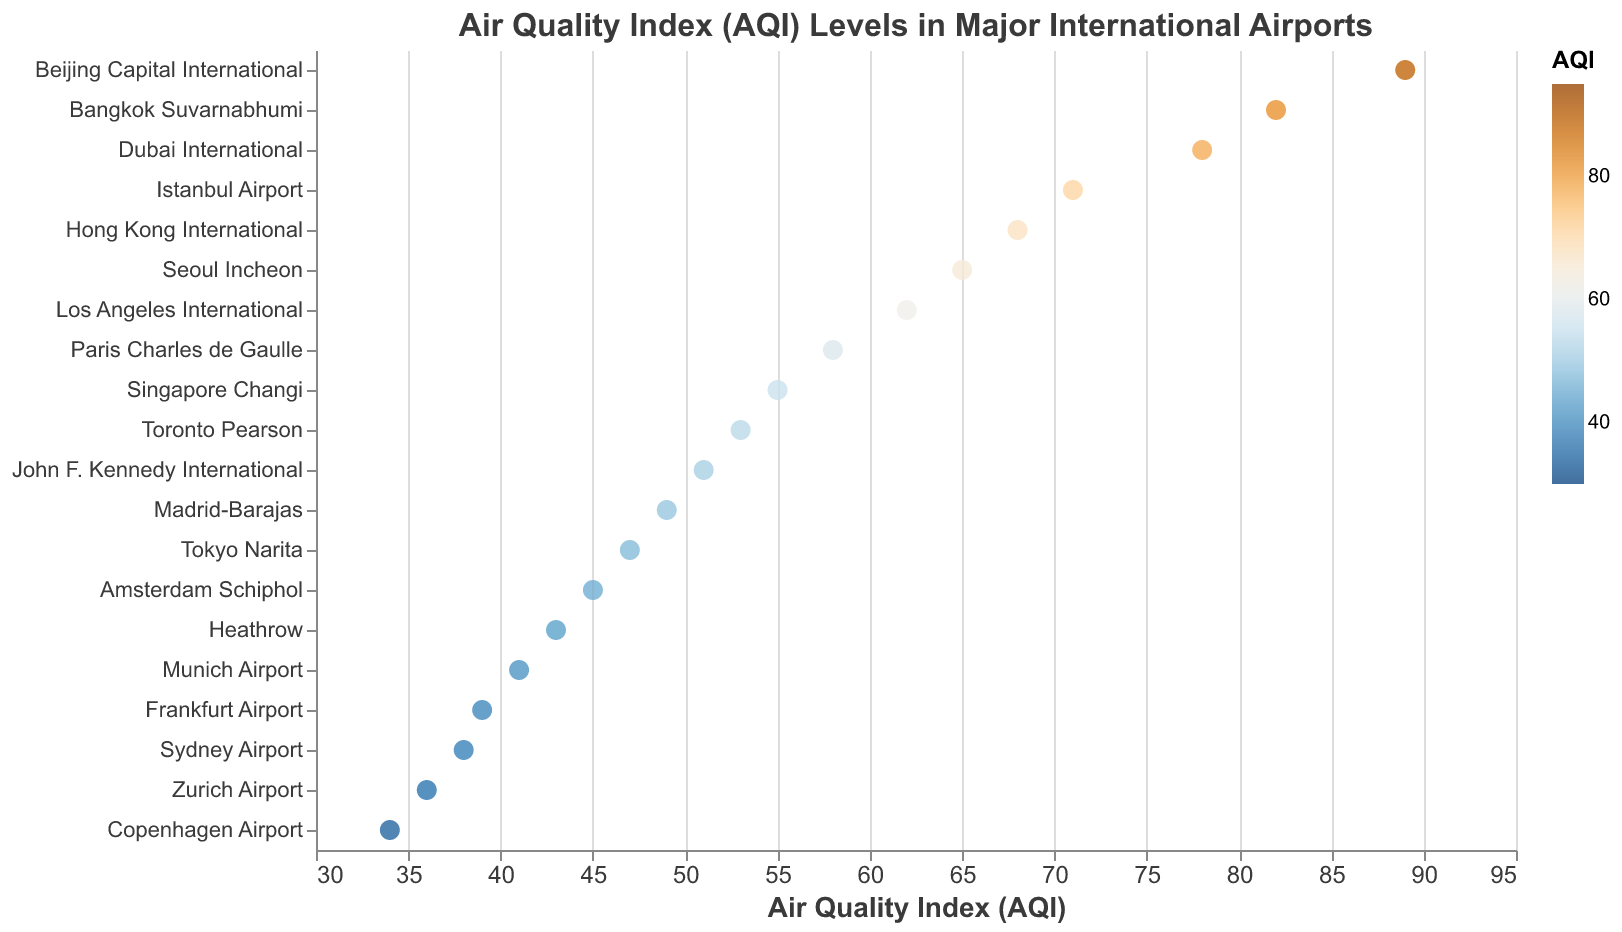What's the highest AQI value among the listed airports? Look for the highest AQI value on the x-axis to identify the airport with the highest AQI. Beijing Capital International has the highest AQI value of 89.
Answer: 89 Which airport has the lowest AQI value? To find the lowest AQI value, identify the lowest value on the x-axis. Copenhagen Airport has the lowest AQI of 34.
Answer: Copenhagen Airport What is the range of AQI values in the figure? The range is the difference between the highest and lowest AQI values. The highest is 89 (Beijing Capital International) and the lowest is 34 (Copenhagen Airport). So, the range is 89 - 34 = 55.
Answer: 55 How many airports have an AQI greater than 70? Count the number of data points to the right of AQI 70 on the x-axis. There are 4 airports: Beijing Capital International, Bangkok Suvarnabhumi, Istanbul Airport, and Dubai International.
Answer: 4 Which airport has a similar AQI to Madrid-Barajas? The AQI of Madrid-Barajas is 49. Look for other data points near AQI 49. Tokyo Narita (47) and Amsterdam Schiphol (45) are close, but none match exactly.
Answer: Tokyo Narita and Amsterdam Schiphol Which airports have AQI values between 50 and 60? Identify and list the airports with AQI values between 50 and 60 by looking at points within this range on the x-axis. They are Paris Charles de Gaulle, Singapore Changi, John F. Kennedy International, and Toronto Pearson.
Answer: Paris Charles de Gaulle, Singapore Changi, John F. Kennedy International, Toronto Pearson What is the average AQI value of all the listed airports? Sum the AQI values of all airports and divide by the number of airports. Total AQI = 62 + 43 + 78 + 55 + 51 + 39 + 68 + 47 + 58 + 45 + 89 + 38 + 53 + 71 + 41 + 36 + 65 + 82 + 49 + 34 = 1064. The number of airports is 20. Average AQI = 1064 / 20 = 53.2.
Answer: 53.2 Which airport has a higher AQI: Heathrow or Frankfurt Airport? Compare the AQIs of Heathrow (43) and Frankfurt Airport (39). Heathrow has a higher AQI.
Answer: Heathrow Is there a noticeable pattern in the color distribution related to AQI values? By analyzing the color gradient, it appears that AQI values are represented by a blue-to-orange color scheme, with lower AQIs shown in blue and higher AQIs in orange.
Answer: Yes How does the AQI of Los Angeles International compare to the overall average AQI? The AQI for Los Angeles International is 62. The average AQI is 53.2. Los Angeles International has a higher AQI than the average.
Answer: Higher 